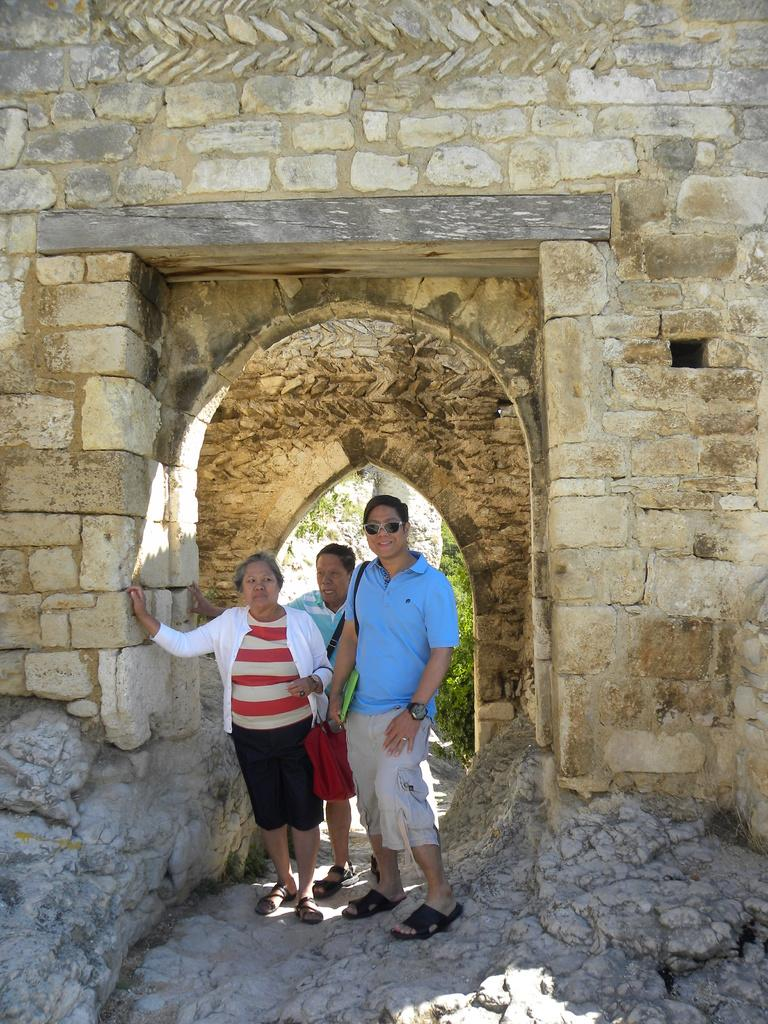What are the people in the image doing? The group of people is standing on the ground in the image. What can be seen in the background of the image? There is a stone wall, arches, and a group of trees in the background. What type of drug is the goose carrying in the image? There is no goose or drug present in the image. 